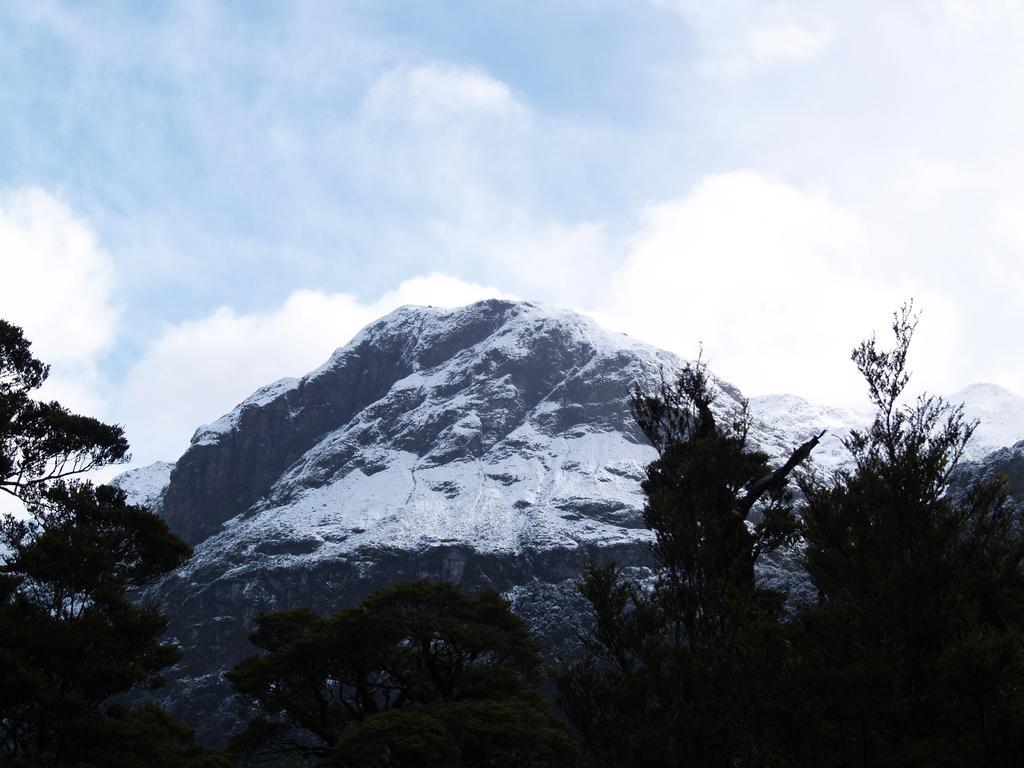Describe this image in one or two sentences. These look like the snowy mountains. I can see the trees. These are the clouds in the sky. 